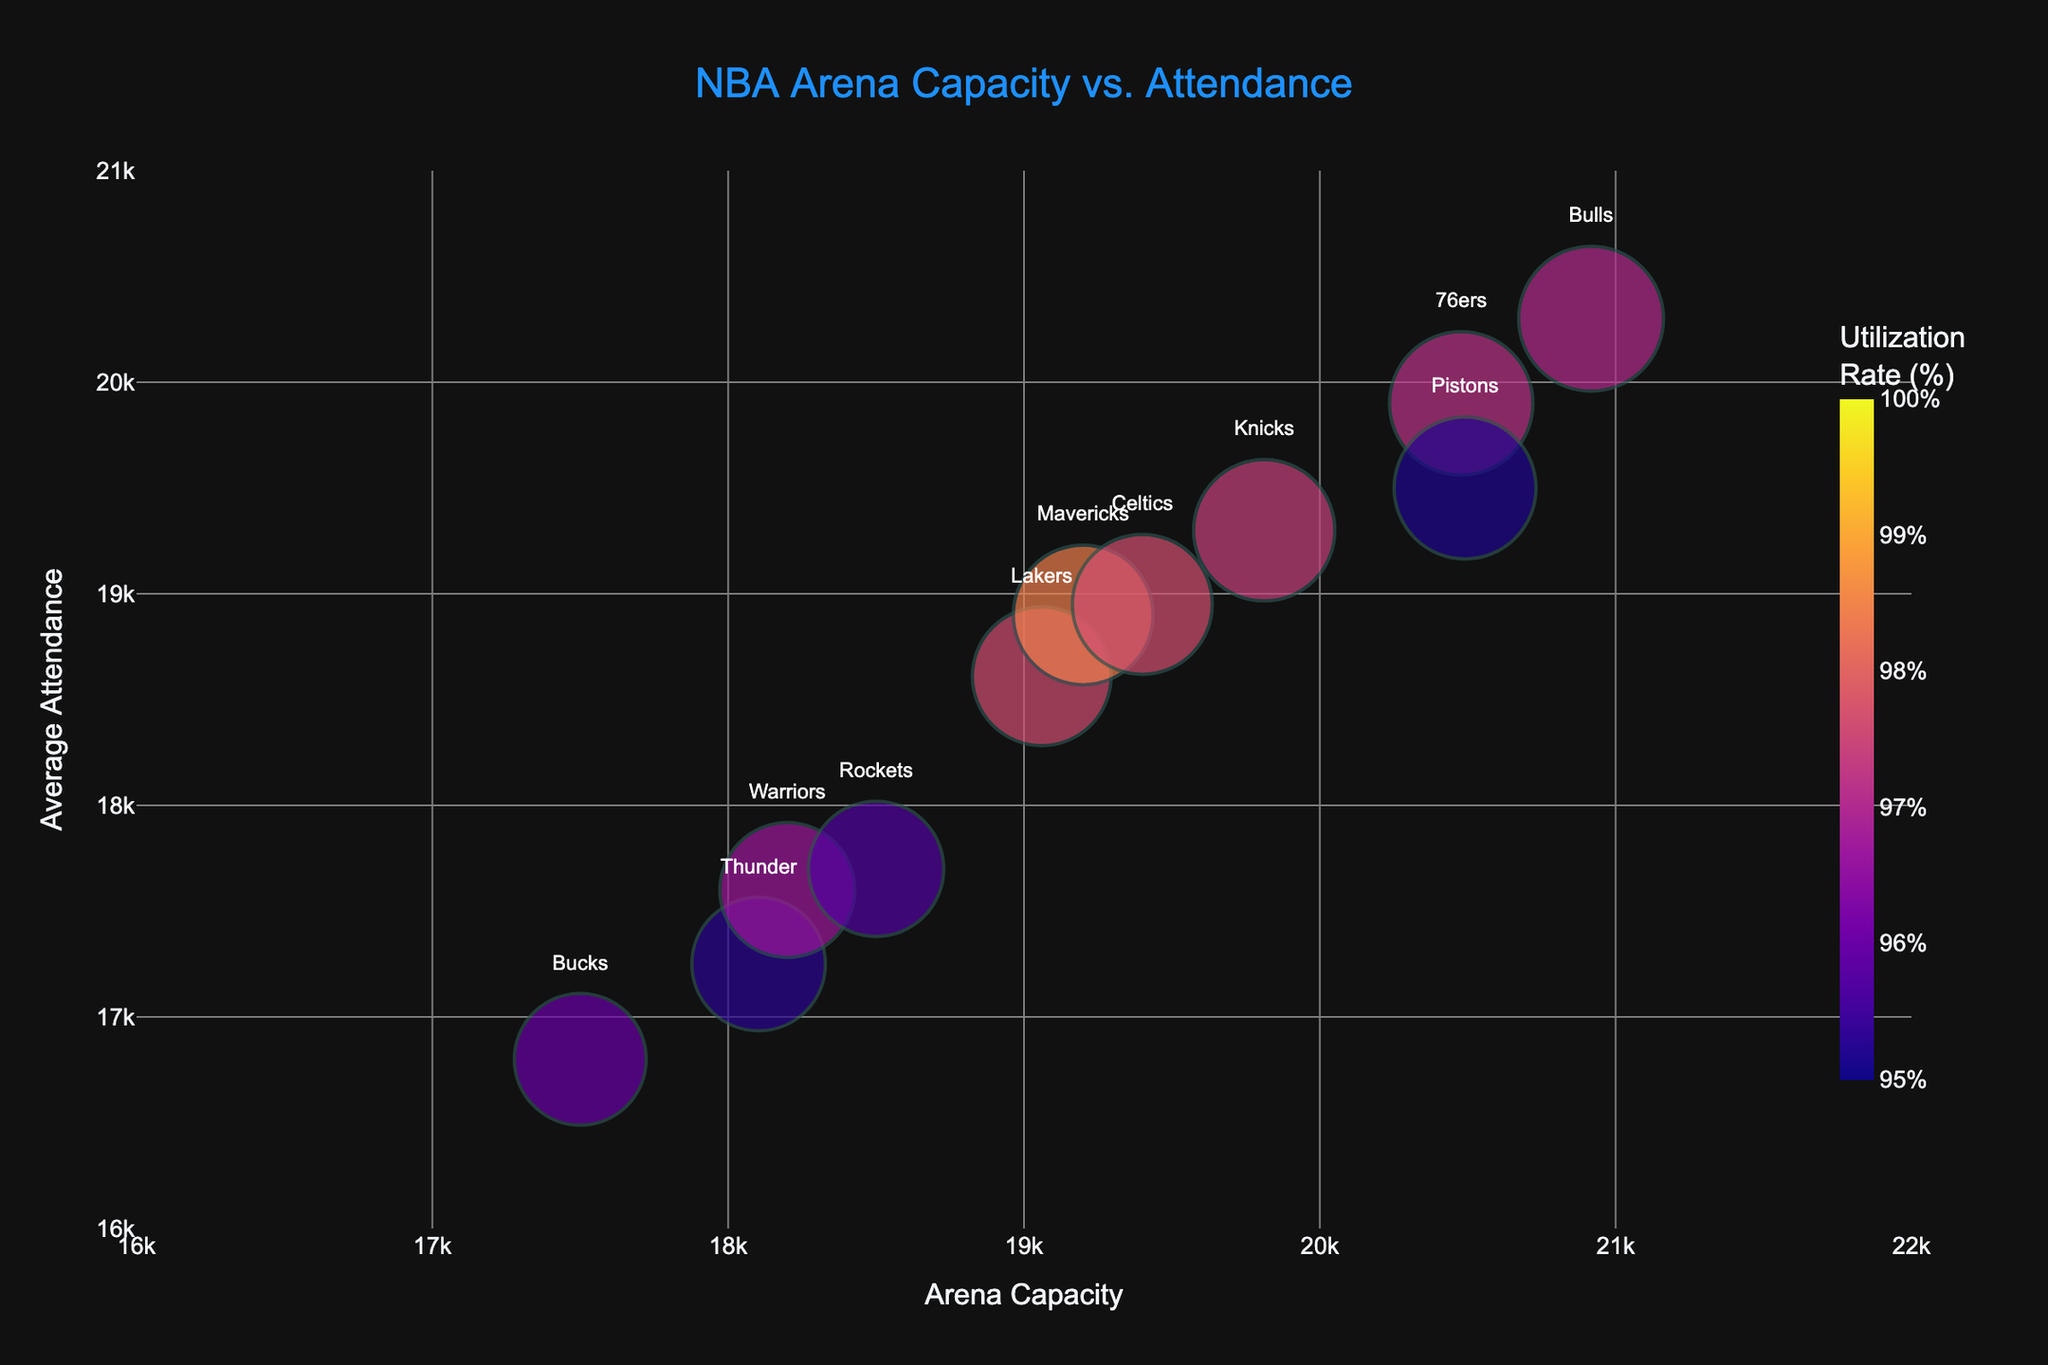What's the title of the chart? The title of the chart is usually positioned at the top and is prominently displayed.
Answer: NBA Arena Capacity vs. Attendance Which NBA team has the highest average attendance? To find the highest average attendance, look at the y-axis (Average Attendance) and identify the data point that is the highest. The Madison Square Garden data point (New York Knicks) reaches 19300, which is the highest.
Answer: New York Knicks What is the utilization rate of the Staples Center? The color of the bubbles represents the Utilization Rate. By looking at the color nearby Staples Center (Los Angeles Lakers), it falls between 95-100%. The exact rate is visible in the hover information too.
Answer: 97.64% What is the range of arena capacities shown on the x-axis? The x-axis represents Arena Capacity, ranging from the smallest on the left to the largest on the right. According to the axis range, it spans from 16000 to 22000.
Answer: 16000 to 22000 Between the Chesapeake Energy Arena and the American Airlines Center, which has a higher Utilization Rate? Identify both arenas on the plot and compare their colors representing the Utilization Rate. Chesapeake Energy Arena (Thunder) has 95.28% while American Airlines Center (Mavericks) has 98.44%.
Answer: American Airlines Center Which team has the lowest average attendance, and what is that attendance? Find the data point lowest on the y-axis which represents Average Attendance. The lowest point is the Fiserv Forum (Milwaukee Bucks) at 16800.
Answer: Milwaukee Bucks, 16800 If the Wells Fargo Center increases its average attendance by 1000, what will be its utilization rate? The current Utilization Rate can be recalculated by the formula [(Average Attendance + 1000) / Capacity] * 100%. Wells Fargo Center's new attendance would be 20900, and the new utilization rate = (20900/20478) * 100% ≈ 102.06%.
Answer: 102.06% Which arena on the plot has the highest Utilization Rate, and what is its value? The arena with the darkest color bubble on the chart represents the highest Utilization Rate. American Airlines Center (Mavericks) is the darkest and represents 98.44%.
Answer: American Airlines Center, 98.44% Are there any arenas where the average attendance exceeds the capacity? If so, name them. To check if average attendance exceeds capacity, compare y-axis values (Average Attendance) with x-axis values (Capacity). The figure's range doesn't explicitly show any exceedance, as all y-values fall below the upper x-values limit.
Answer: No 